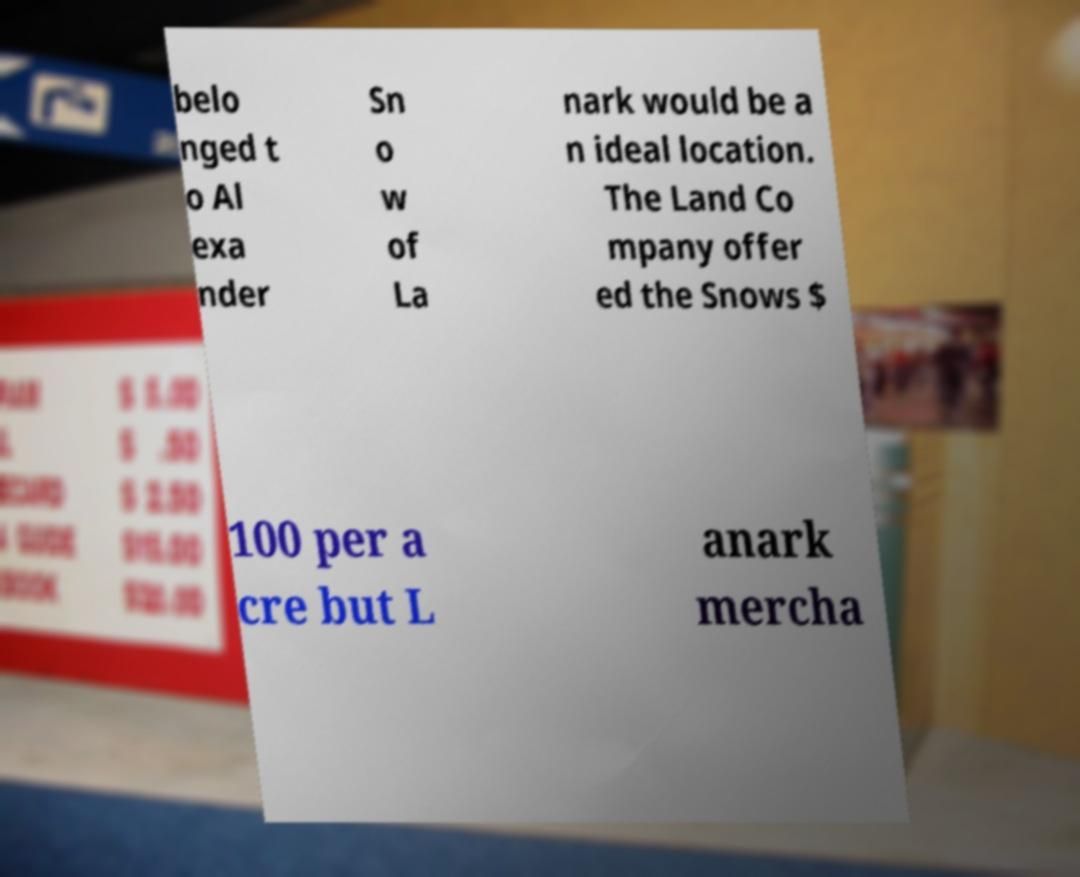For documentation purposes, I need the text within this image transcribed. Could you provide that? belo nged t o Al exa nder Sn o w of La nark would be a n ideal location. The Land Co mpany offer ed the Snows $ 100 per a cre but L anark mercha 